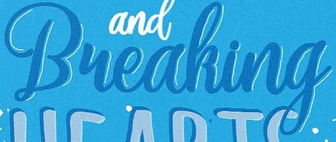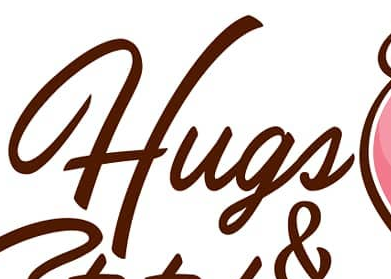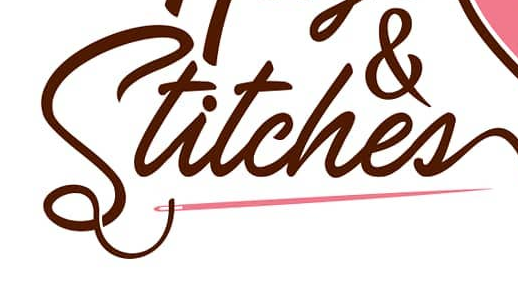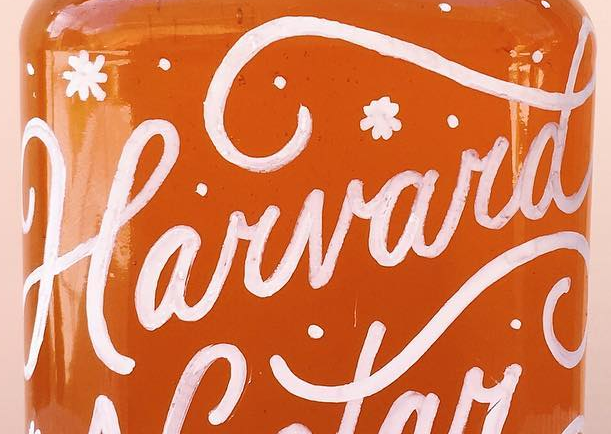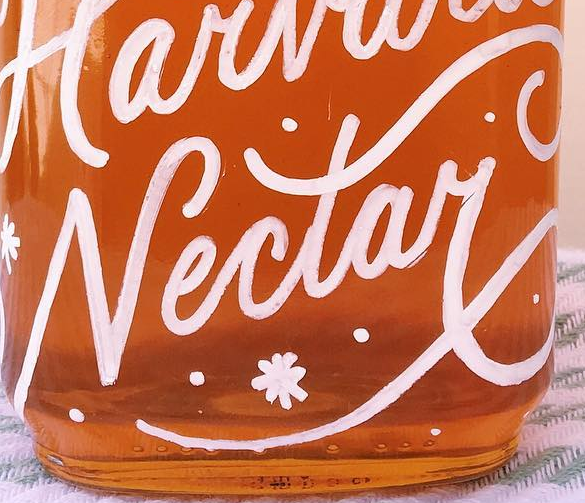Read the text from these images in sequence, separated by a semicolon. Bueaking; Hugs; Stitches; Harvard; Nectay 